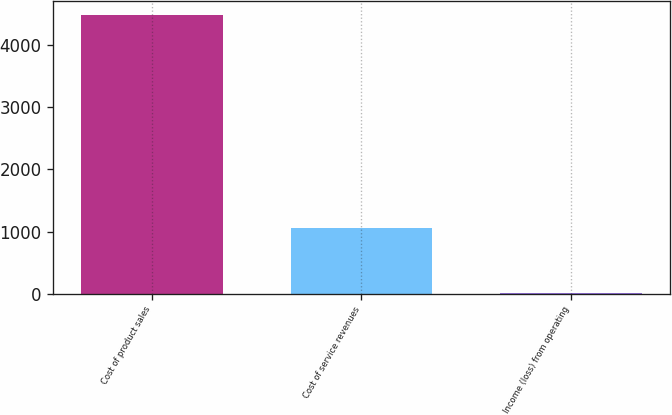<chart> <loc_0><loc_0><loc_500><loc_500><bar_chart><fcel>Cost of product sales<fcel>Cost of service revenues<fcel>Income (loss) from operating<nl><fcel>4489<fcel>1051<fcel>11<nl></chart> 